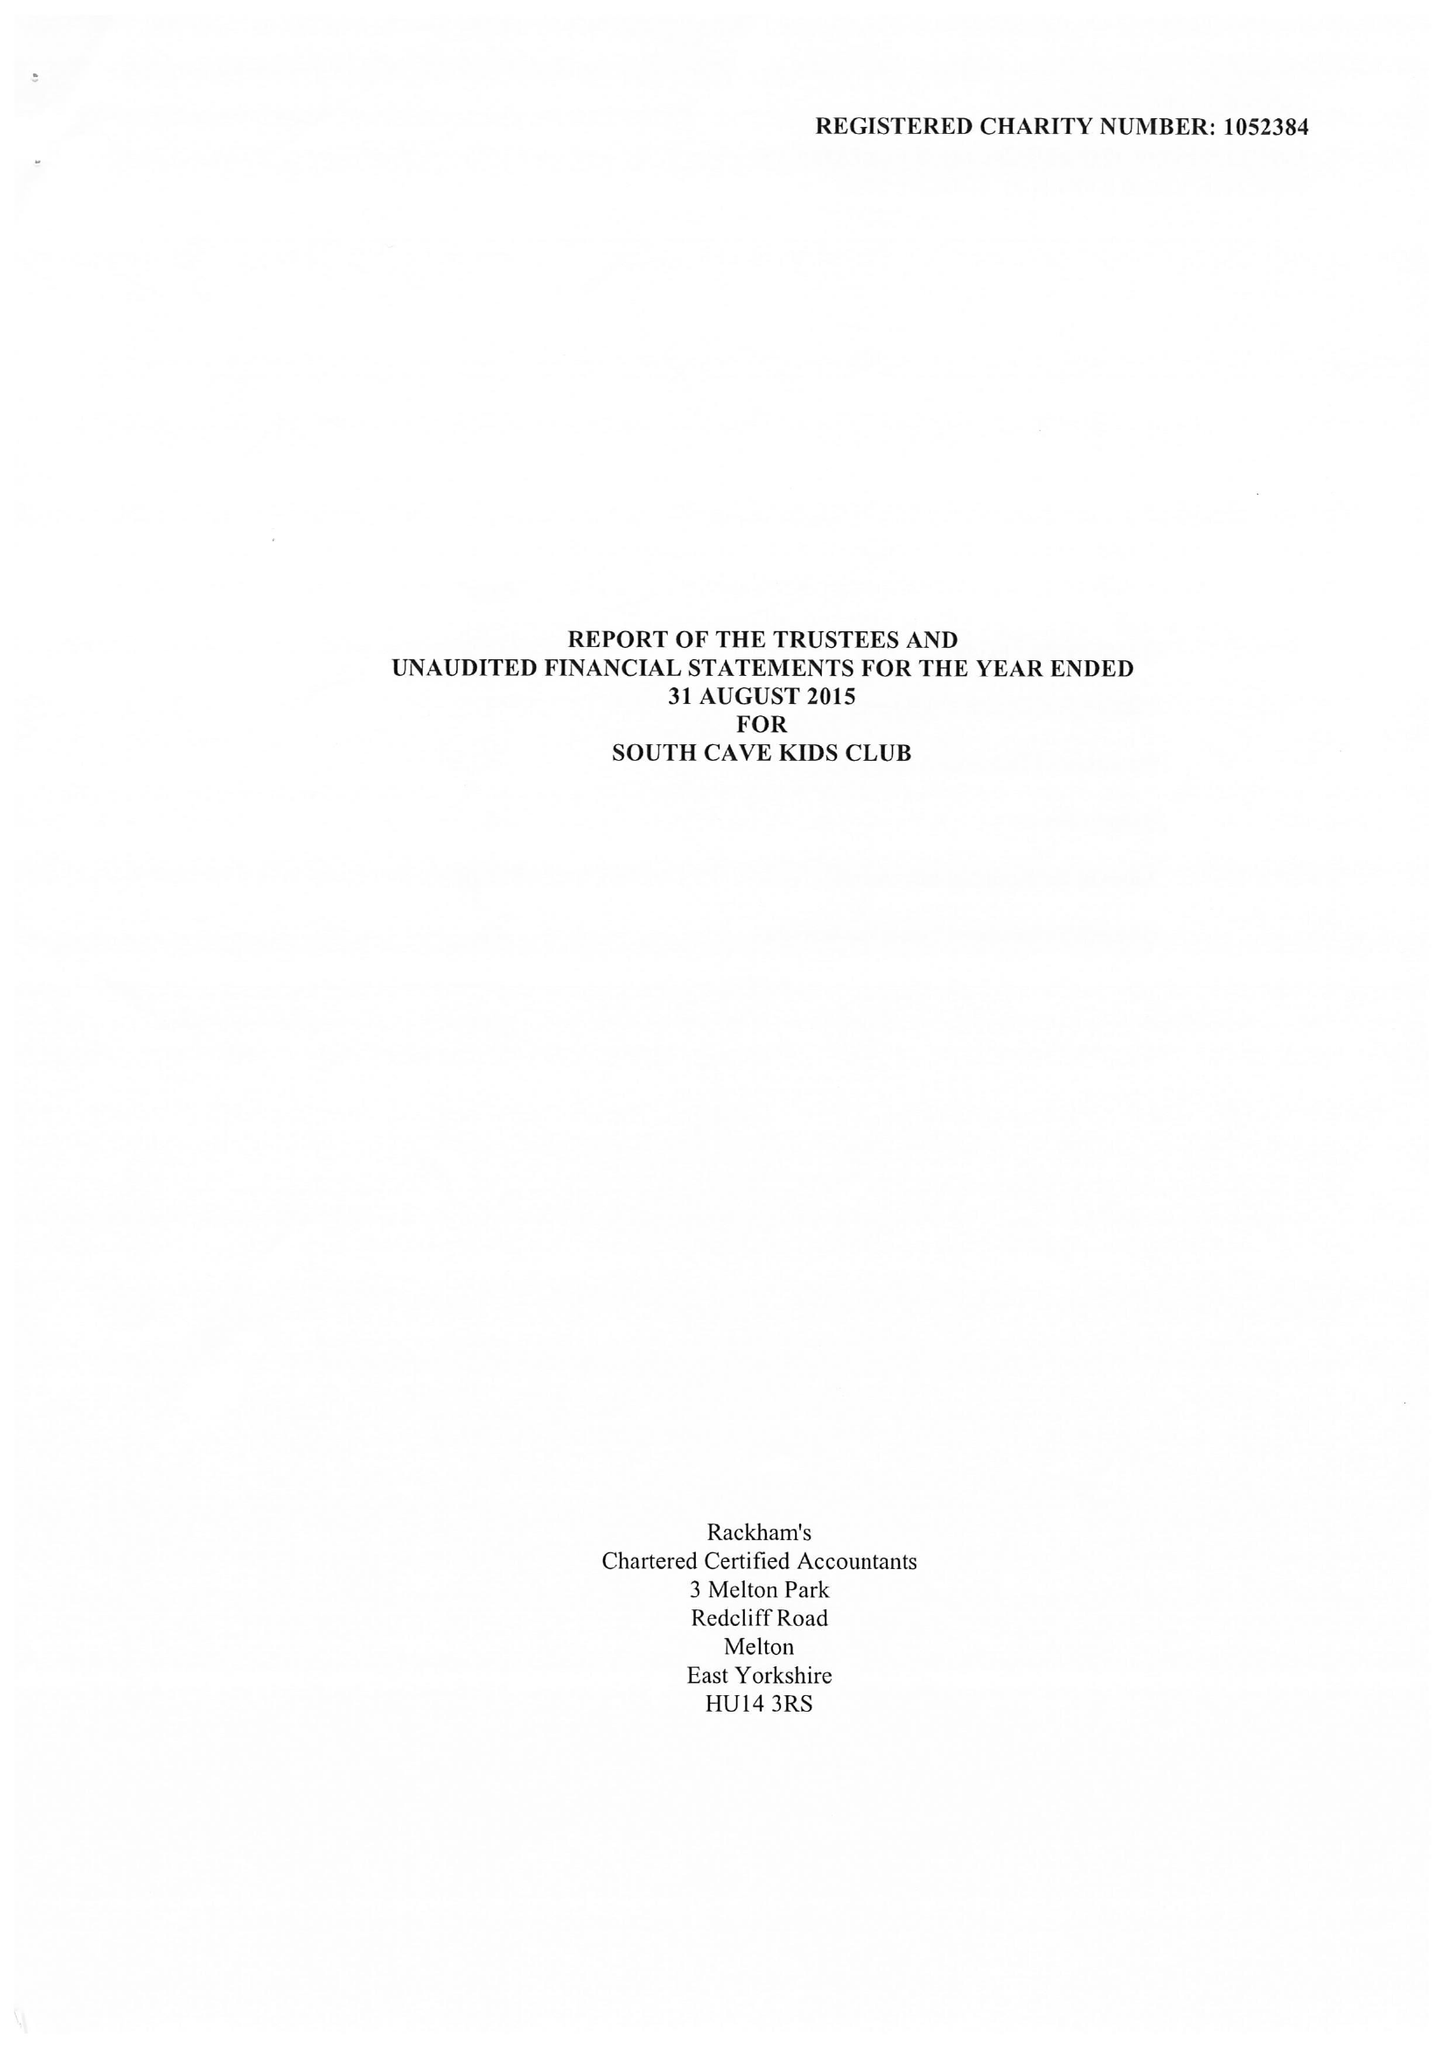What is the value for the address__street_line?
Answer the question using a single word or phrase. CHURCH STREET 